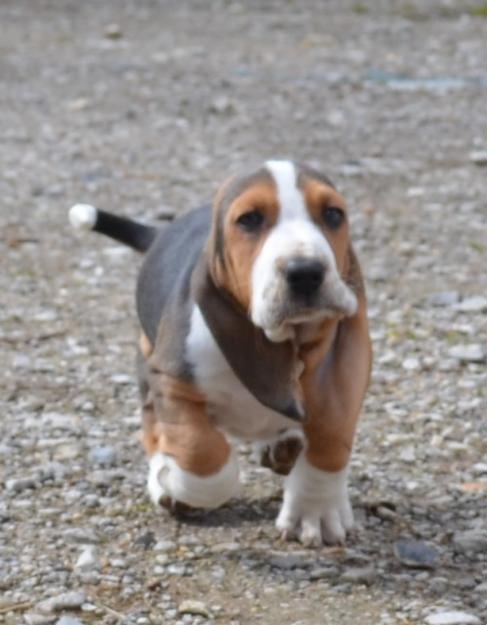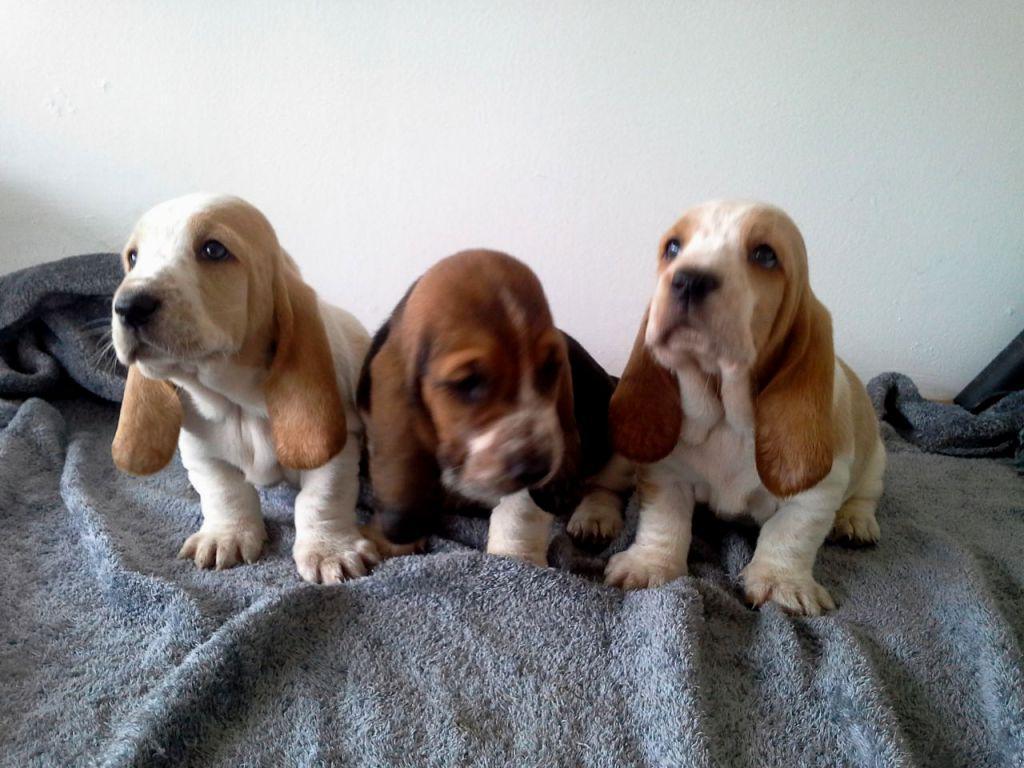The first image is the image on the left, the second image is the image on the right. Considering the images on both sides, is "One image shows a basset hound licking an animal that is not a dog." valid? Answer yes or no. No. The first image is the image on the left, the second image is the image on the right. Assess this claim about the two images: "In one image the only animal is the basset hound, but in the second there is a basset hound with a different species.". Correct or not? Answer yes or no. No. 